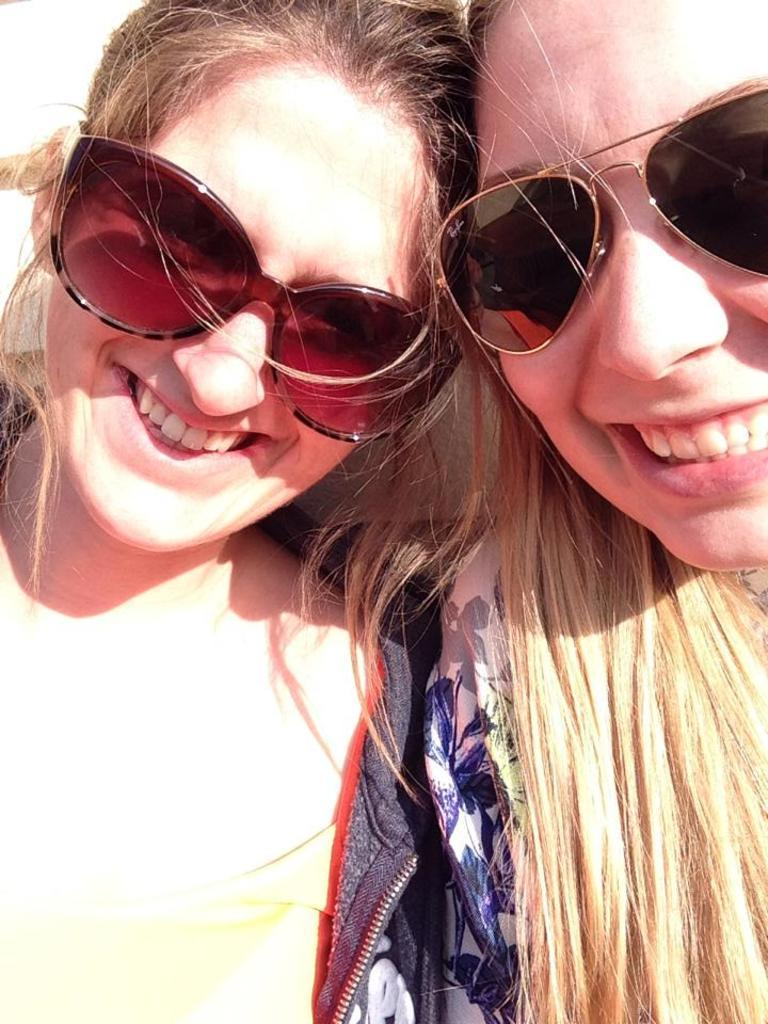How many people are in the image? There are two ladies in the image. What are the ladies wearing in the image? Both ladies are wearing glasses. What expression do the ladies have in the image? Both ladies are smiling. What type of music can be heard coming from the snails in the image? There are no snails present in the image, so it's not possible to determine what, if any, music might be heard. 